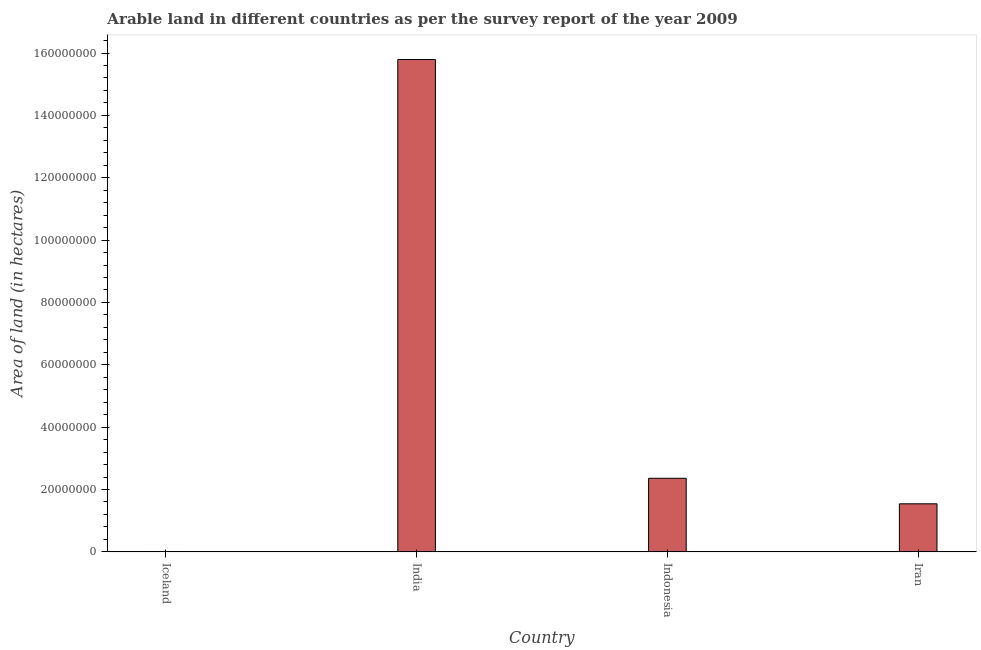What is the title of the graph?
Your answer should be compact. Arable land in different countries as per the survey report of the year 2009. What is the label or title of the Y-axis?
Offer a very short reply. Area of land (in hectares). What is the area of land in India?
Offer a terse response. 1.58e+08. Across all countries, what is the maximum area of land?
Provide a short and direct response. 1.58e+08. Across all countries, what is the minimum area of land?
Offer a very short reply. 1.24e+05. In which country was the area of land maximum?
Provide a succinct answer. India. In which country was the area of land minimum?
Keep it short and to the point. Iceland. What is the sum of the area of land?
Your answer should be compact. 1.97e+08. What is the difference between the area of land in India and Indonesia?
Your answer should be very brief. 1.34e+08. What is the average area of land per country?
Offer a very short reply. 4.93e+07. What is the median area of land?
Keep it short and to the point. 1.95e+07. What is the ratio of the area of land in India to that in Iran?
Offer a terse response. 10.25. What is the difference between the highest and the second highest area of land?
Make the answer very short. 1.34e+08. What is the difference between the highest and the lowest area of land?
Provide a succinct answer. 1.58e+08. In how many countries, is the area of land greater than the average area of land taken over all countries?
Your response must be concise. 1. How many countries are there in the graph?
Keep it short and to the point. 4. Are the values on the major ticks of Y-axis written in scientific E-notation?
Your answer should be very brief. No. What is the Area of land (in hectares) of Iceland?
Keep it short and to the point. 1.24e+05. What is the Area of land (in hectares) in India?
Your answer should be compact. 1.58e+08. What is the Area of land (in hectares) in Indonesia?
Your answer should be very brief. 2.36e+07. What is the Area of land (in hectares) of Iran?
Your answer should be compact. 1.54e+07. What is the difference between the Area of land (in hectares) in Iceland and India?
Provide a short and direct response. -1.58e+08. What is the difference between the Area of land (in hectares) in Iceland and Indonesia?
Ensure brevity in your answer.  -2.35e+07. What is the difference between the Area of land (in hectares) in Iceland and Iran?
Your answer should be compact. -1.53e+07. What is the difference between the Area of land (in hectares) in India and Indonesia?
Your answer should be compact. 1.34e+08. What is the difference between the Area of land (in hectares) in India and Iran?
Make the answer very short. 1.43e+08. What is the difference between the Area of land (in hectares) in Indonesia and Iran?
Your answer should be very brief. 8.19e+06. What is the ratio of the Area of land (in hectares) in Iceland to that in India?
Ensure brevity in your answer.  0. What is the ratio of the Area of land (in hectares) in Iceland to that in Indonesia?
Offer a very short reply. 0.01. What is the ratio of the Area of land (in hectares) in Iceland to that in Iran?
Give a very brief answer. 0.01. What is the ratio of the Area of land (in hectares) in India to that in Indonesia?
Provide a short and direct response. 6.69. What is the ratio of the Area of land (in hectares) in India to that in Iran?
Your response must be concise. 10.25. What is the ratio of the Area of land (in hectares) in Indonesia to that in Iran?
Offer a very short reply. 1.53. 